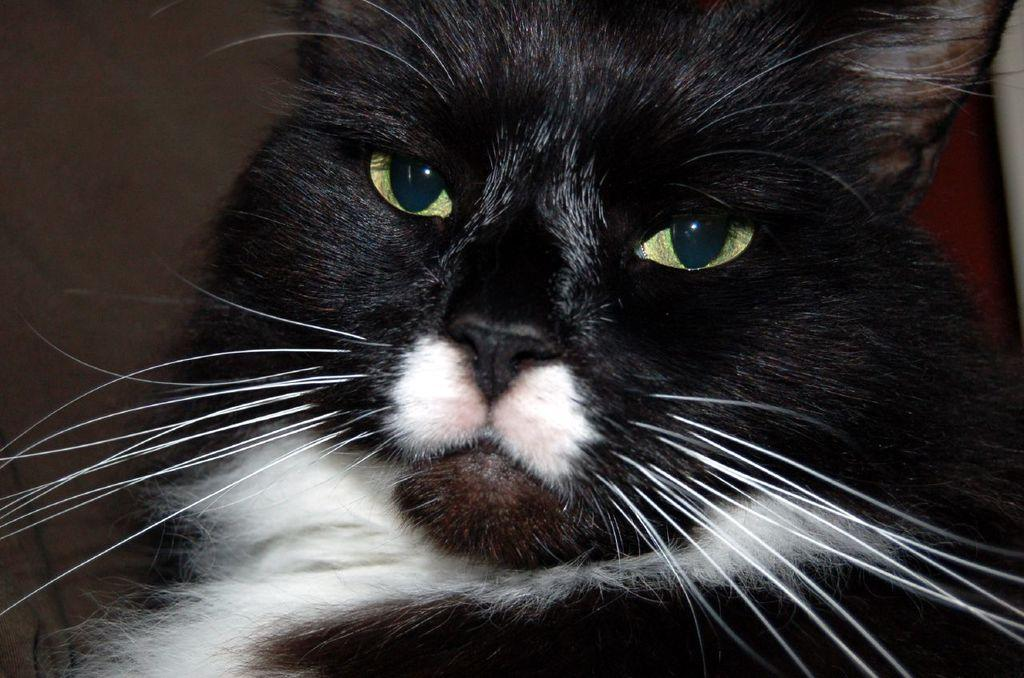What type of animal is in the image? There is a cat in the image. What is the color of the cat? The cat is black in color. What facial features does the cat have? The cat has eyes, a nose, and a mouth. What other feature is present on the cat's face? The cat has whiskers. What type of trousers is the cat wearing in the image? Cats do not wear trousers, so this detail cannot be found in the image. 